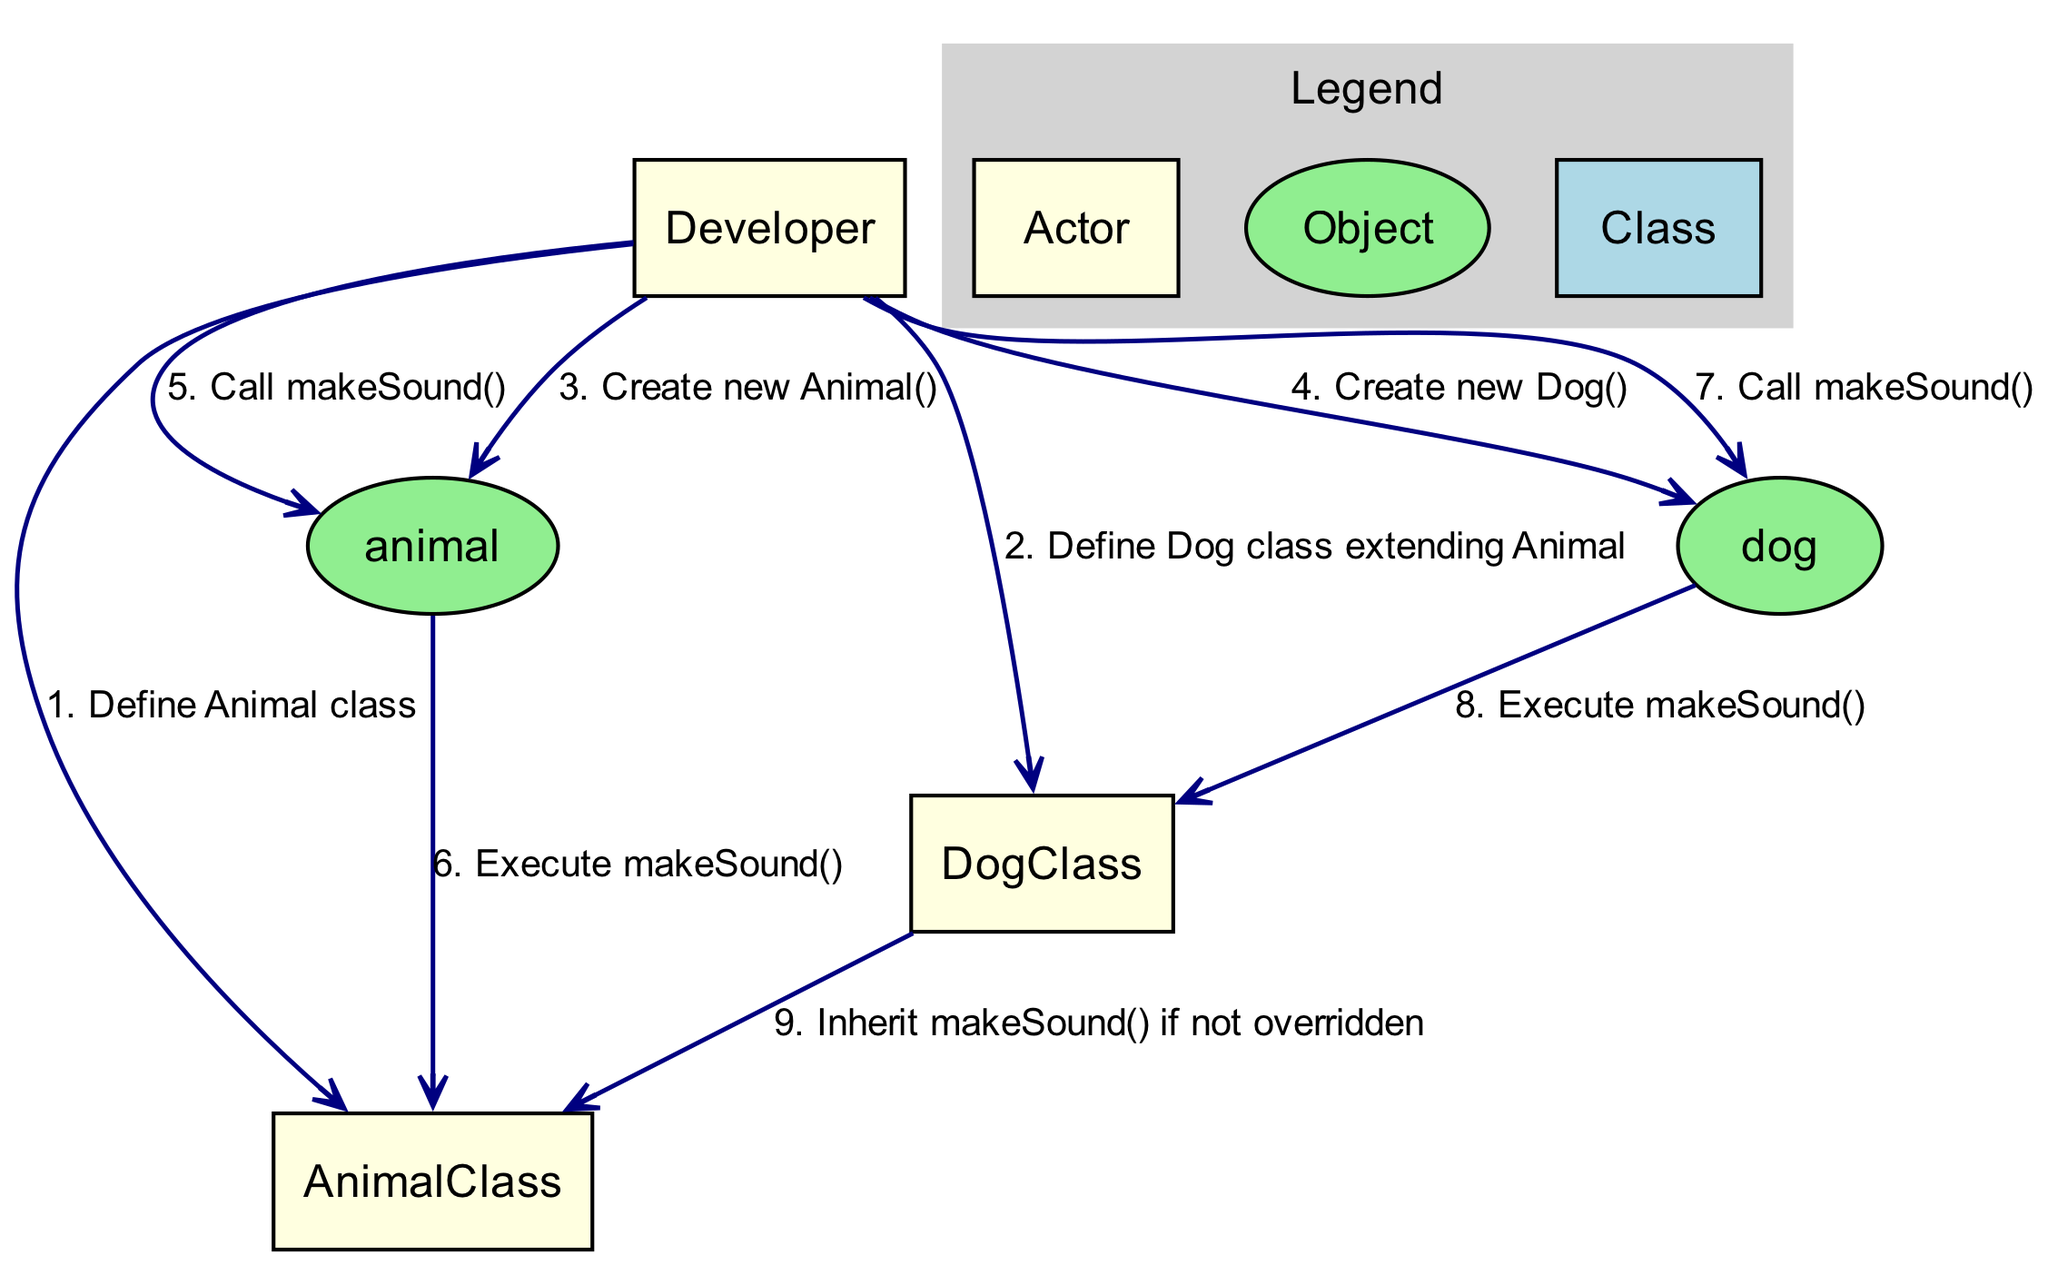What are the names of the classes defined in the diagram? The diagram shows two classes defined: Animal and Dog.
Answer: Animal, Dog How many objects are created in the sequence? The sequence shows the creation of two objects: one Animal and one Dog.
Answer: 2 Who invokes the makeSound() method on the animal object? The Developer is the person who invokes the makeSound() method on the animal object.
Answer: Developer Which class does the Dog class extend? The Dog class extends the Animal class, indicating a parent-child relationship in inheritance.
Answer: Animal What does the DogClass inherit if the makeSound() method is not overridden? If the makeSound() method is not overridden in DogClass, it inherits this method from AnimalClass as indicated in the diagram.
Answer: makeSound() What happens when makeSound() is called on the dog object? When makeSound() is called on the dog object, it will execute its own implementation in DogClass unless overridden, otherwise, it follows the inheritance chain.
Answer: Execute makeSound() What is the order of interaction when the Developer creates the new Dog object? The Developer first defines the Dog class extending Animal, then invokes the creation of the dog object by calling new Dog().
Answer: Define Dog class extending Animal, Create new Dog() In total, how many interactions are depicted in the sequence diagram? The diagram shows a total of nine interactions taking place among developers, classes, and objects.
Answer: 9 Which actor is responsible for defining the Animal class? The Developer is responsible for defining the Animal class, as indicated in the diagram's interactions.
Answer: Developer 